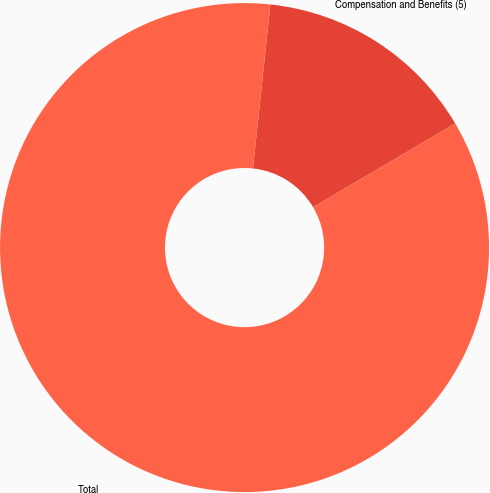Convert chart. <chart><loc_0><loc_0><loc_500><loc_500><pie_chart><fcel>Compensation and Benefits (5)<fcel>Total<nl><fcel>14.84%<fcel>85.16%<nl></chart> 